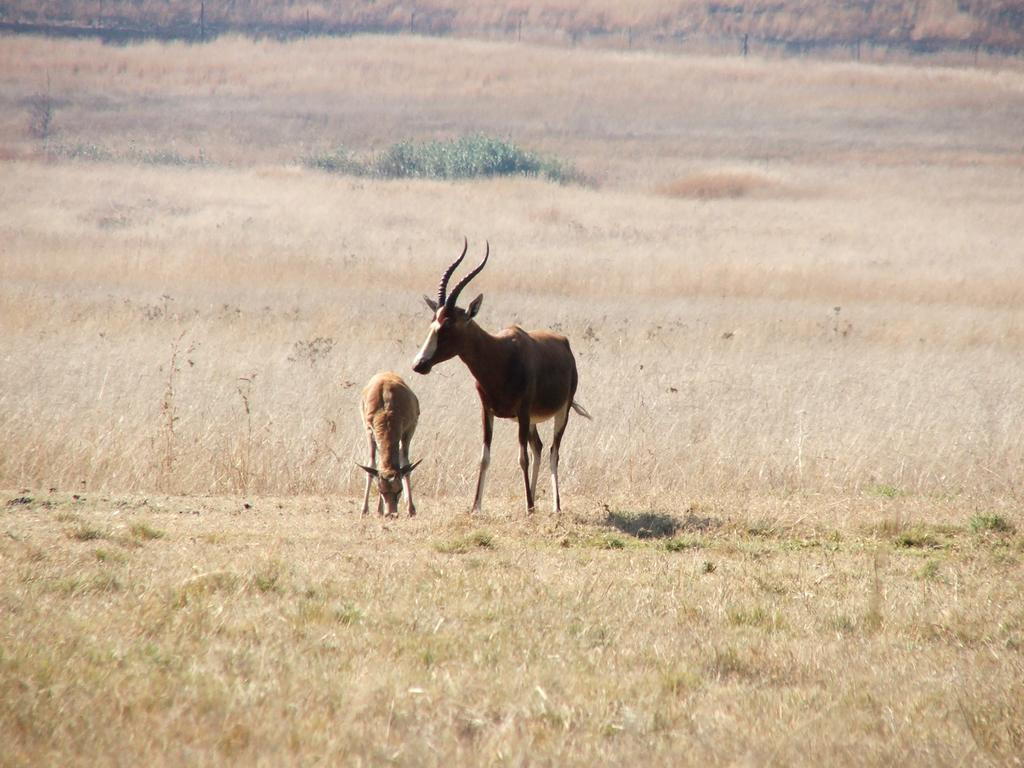What type of vegetation can be seen in the image? There is grass in the image. What other living organisms are present in the image? There are animals in the image. How would you describe the condition of the grass in the image? The land is covered with dried grass. What year is depicted in the image? The image does not depict a specific year; it is a snapshot of a grassy area with animals. What type of debt is being discussed in the image? There is no mention or depiction of debt in the image; it focuses on grass and animals. 